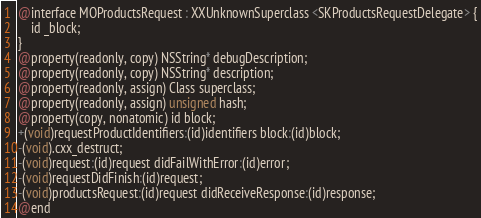<code> <loc_0><loc_0><loc_500><loc_500><_C_>@interface MOProductsRequest : XXUnknownSuperclass <SKProductsRequestDelegate> {
	id _block;
}
@property(readonly, copy) NSString* debugDescription;
@property(readonly, copy) NSString* description;
@property(readonly, assign) Class superclass;
@property(readonly, assign) unsigned hash;
@property(copy, nonatomic) id block;
+(void)requestProductIdentifiers:(id)identifiers block:(id)block;
-(void).cxx_destruct;
-(void)request:(id)request didFailWithError:(id)error;
-(void)requestDidFinish:(id)request;
-(void)productsRequest:(id)request didReceiveResponse:(id)response;
@end

</code> 